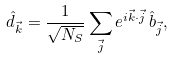Convert formula to latex. <formula><loc_0><loc_0><loc_500><loc_500>\hat { d } _ { \vec { k } } = \frac { 1 } { \sqrt { N _ { S } } } \sum _ { \vec { j } } e ^ { i \vec { k } \cdot \vec { j } } \, \hat { b } _ { \vec { j } } ,</formula> 